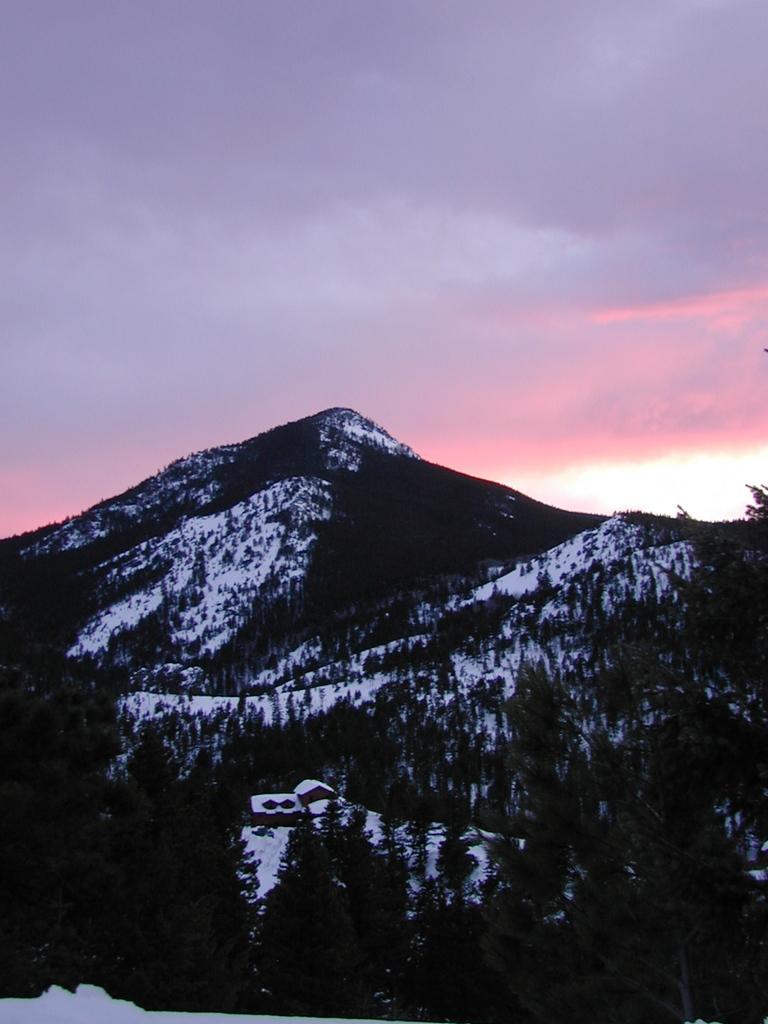How would you summarize this image in a sentence or two? In this image, we can see some mountains, trees. We can also see a house and some snow. We can also see the sky with clouds. 